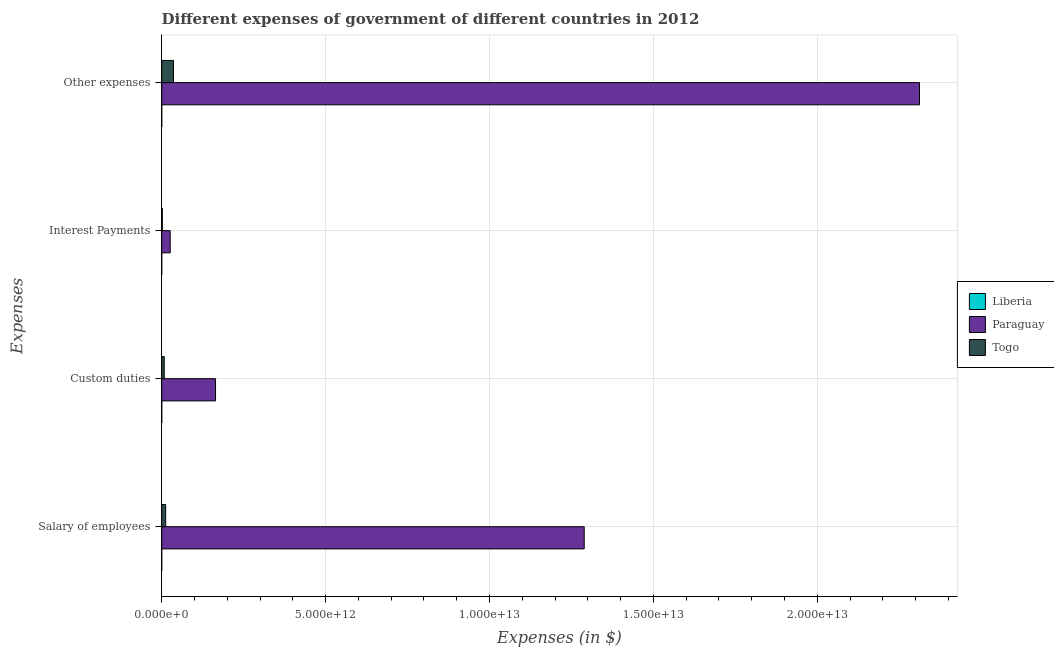Are the number of bars on each tick of the Y-axis equal?
Your answer should be very brief. Yes. How many bars are there on the 2nd tick from the top?
Provide a short and direct response. 3. What is the label of the 4th group of bars from the top?
Ensure brevity in your answer.  Salary of employees. What is the amount spent on salary of employees in Liberia?
Make the answer very short. 2.47e+06. Across all countries, what is the maximum amount spent on salary of employees?
Your answer should be very brief. 1.29e+13. Across all countries, what is the minimum amount spent on custom duties?
Provide a succinct answer. 1.73e+06. In which country was the amount spent on custom duties maximum?
Offer a terse response. Paraguay. In which country was the amount spent on custom duties minimum?
Your response must be concise. Liberia. What is the total amount spent on custom duties in the graph?
Your answer should be compact. 1.72e+12. What is the difference between the amount spent on custom duties in Togo and that in Liberia?
Ensure brevity in your answer.  7.70e+1. What is the difference between the amount spent on interest payments in Paraguay and the amount spent on salary of employees in Togo?
Offer a very short reply. 1.39e+11. What is the average amount spent on salary of employees per country?
Keep it short and to the point. 4.34e+12. What is the difference between the amount spent on salary of employees and amount spent on custom duties in Togo?
Provide a succinct answer. 4.34e+1. What is the ratio of the amount spent on interest payments in Liberia to that in Togo?
Provide a succinct answer. 2.492294683419937e-6. Is the amount spent on other expenses in Togo less than that in Liberia?
Give a very brief answer. No. Is the difference between the amount spent on salary of employees in Togo and Liberia greater than the difference between the amount spent on custom duties in Togo and Liberia?
Provide a short and direct response. Yes. What is the difference between the highest and the second highest amount spent on interest payments?
Give a very brief answer. 2.41e+11. What is the difference between the highest and the lowest amount spent on interest payments?
Offer a terse response. 2.59e+11. Is the sum of the amount spent on interest payments in Togo and Liberia greater than the maximum amount spent on custom duties across all countries?
Keep it short and to the point. No. What does the 3rd bar from the top in Salary of employees represents?
Offer a terse response. Liberia. What does the 1st bar from the bottom in Custom duties represents?
Make the answer very short. Liberia. Is it the case that in every country, the sum of the amount spent on salary of employees and amount spent on custom duties is greater than the amount spent on interest payments?
Offer a very short reply. Yes. What is the difference between two consecutive major ticks on the X-axis?
Ensure brevity in your answer.  5.00e+12. Are the values on the major ticks of X-axis written in scientific E-notation?
Your answer should be compact. Yes. What is the title of the graph?
Your answer should be compact. Different expenses of government of different countries in 2012. What is the label or title of the X-axis?
Your response must be concise. Expenses (in $). What is the label or title of the Y-axis?
Make the answer very short. Expenses. What is the Expenses (in $) of Liberia in Salary of employees?
Offer a very short reply. 2.47e+06. What is the Expenses (in $) of Paraguay in Salary of employees?
Offer a terse response. 1.29e+13. What is the Expenses (in $) in Togo in Salary of employees?
Ensure brevity in your answer.  1.20e+11. What is the Expenses (in $) of Liberia in Custom duties?
Ensure brevity in your answer.  1.73e+06. What is the Expenses (in $) of Paraguay in Custom duties?
Ensure brevity in your answer.  1.64e+12. What is the Expenses (in $) in Togo in Custom duties?
Ensure brevity in your answer.  7.70e+1. What is the Expenses (in $) in Liberia in Interest Payments?
Give a very brief answer. 4.63e+04. What is the Expenses (in $) of Paraguay in Interest Payments?
Your answer should be very brief. 2.59e+11. What is the Expenses (in $) in Togo in Interest Payments?
Provide a short and direct response. 1.86e+1. What is the Expenses (in $) in Liberia in Other expenses?
Provide a succinct answer. 5.86e+06. What is the Expenses (in $) in Paraguay in Other expenses?
Offer a terse response. 2.31e+13. What is the Expenses (in $) in Togo in Other expenses?
Ensure brevity in your answer.  3.60e+11. Across all Expenses, what is the maximum Expenses (in $) of Liberia?
Ensure brevity in your answer.  5.86e+06. Across all Expenses, what is the maximum Expenses (in $) of Paraguay?
Ensure brevity in your answer.  2.31e+13. Across all Expenses, what is the maximum Expenses (in $) in Togo?
Your answer should be very brief. 3.60e+11. Across all Expenses, what is the minimum Expenses (in $) of Liberia?
Provide a short and direct response. 4.63e+04. Across all Expenses, what is the minimum Expenses (in $) of Paraguay?
Your answer should be very brief. 2.59e+11. Across all Expenses, what is the minimum Expenses (in $) in Togo?
Provide a short and direct response. 1.86e+1. What is the total Expenses (in $) in Liberia in the graph?
Make the answer very short. 1.01e+07. What is the total Expenses (in $) of Paraguay in the graph?
Your answer should be compact. 3.79e+13. What is the total Expenses (in $) in Togo in the graph?
Offer a terse response. 5.76e+11. What is the difference between the Expenses (in $) in Liberia in Salary of employees and that in Custom duties?
Keep it short and to the point. 7.37e+05. What is the difference between the Expenses (in $) of Paraguay in Salary of employees and that in Custom duties?
Your answer should be very brief. 1.12e+13. What is the difference between the Expenses (in $) in Togo in Salary of employees and that in Custom duties?
Ensure brevity in your answer.  4.34e+1. What is the difference between the Expenses (in $) in Liberia in Salary of employees and that in Interest Payments?
Give a very brief answer. 2.42e+06. What is the difference between the Expenses (in $) in Paraguay in Salary of employees and that in Interest Payments?
Provide a succinct answer. 1.26e+13. What is the difference between the Expenses (in $) of Togo in Salary of employees and that in Interest Payments?
Keep it short and to the point. 1.02e+11. What is the difference between the Expenses (in $) of Liberia in Salary of employees and that in Other expenses?
Your answer should be very brief. -3.39e+06. What is the difference between the Expenses (in $) of Paraguay in Salary of employees and that in Other expenses?
Provide a short and direct response. -1.02e+13. What is the difference between the Expenses (in $) of Togo in Salary of employees and that in Other expenses?
Ensure brevity in your answer.  -2.39e+11. What is the difference between the Expenses (in $) of Liberia in Custom duties and that in Interest Payments?
Provide a succinct answer. 1.69e+06. What is the difference between the Expenses (in $) in Paraguay in Custom duties and that in Interest Payments?
Provide a succinct answer. 1.38e+12. What is the difference between the Expenses (in $) of Togo in Custom duties and that in Interest Payments?
Make the answer very short. 5.84e+1. What is the difference between the Expenses (in $) of Liberia in Custom duties and that in Other expenses?
Your response must be concise. -4.13e+06. What is the difference between the Expenses (in $) in Paraguay in Custom duties and that in Other expenses?
Keep it short and to the point. -2.15e+13. What is the difference between the Expenses (in $) of Togo in Custom duties and that in Other expenses?
Keep it short and to the point. -2.83e+11. What is the difference between the Expenses (in $) of Liberia in Interest Payments and that in Other expenses?
Keep it short and to the point. -5.81e+06. What is the difference between the Expenses (in $) in Paraguay in Interest Payments and that in Other expenses?
Provide a short and direct response. -2.29e+13. What is the difference between the Expenses (in $) in Togo in Interest Payments and that in Other expenses?
Offer a very short reply. -3.41e+11. What is the difference between the Expenses (in $) of Liberia in Salary of employees and the Expenses (in $) of Paraguay in Custom duties?
Ensure brevity in your answer.  -1.64e+12. What is the difference between the Expenses (in $) in Liberia in Salary of employees and the Expenses (in $) in Togo in Custom duties?
Provide a short and direct response. -7.70e+1. What is the difference between the Expenses (in $) of Paraguay in Salary of employees and the Expenses (in $) of Togo in Custom duties?
Provide a succinct answer. 1.28e+13. What is the difference between the Expenses (in $) of Liberia in Salary of employees and the Expenses (in $) of Paraguay in Interest Payments?
Provide a short and direct response. -2.59e+11. What is the difference between the Expenses (in $) in Liberia in Salary of employees and the Expenses (in $) in Togo in Interest Payments?
Give a very brief answer. -1.86e+1. What is the difference between the Expenses (in $) in Paraguay in Salary of employees and the Expenses (in $) in Togo in Interest Payments?
Give a very brief answer. 1.29e+13. What is the difference between the Expenses (in $) in Liberia in Salary of employees and the Expenses (in $) in Paraguay in Other expenses?
Keep it short and to the point. -2.31e+13. What is the difference between the Expenses (in $) in Liberia in Salary of employees and the Expenses (in $) in Togo in Other expenses?
Offer a very short reply. -3.60e+11. What is the difference between the Expenses (in $) in Paraguay in Salary of employees and the Expenses (in $) in Togo in Other expenses?
Provide a short and direct response. 1.25e+13. What is the difference between the Expenses (in $) of Liberia in Custom duties and the Expenses (in $) of Paraguay in Interest Payments?
Offer a very short reply. -2.59e+11. What is the difference between the Expenses (in $) in Liberia in Custom duties and the Expenses (in $) in Togo in Interest Payments?
Give a very brief answer. -1.86e+1. What is the difference between the Expenses (in $) of Paraguay in Custom duties and the Expenses (in $) of Togo in Interest Payments?
Keep it short and to the point. 1.62e+12. What is the difference between the Expenses (in $) of Liberia in Custom duties and the Expenses (in $) of Paraguay in Other expenses?
Offer a very short reply. -2.31e+13. What is the difference between the Expenses (in $) of Liberia in Custom duties and the Expenses (in $) of Togo in Other expenses?
Provide a succinct answer. -3.60e+11. What is the difference between the Expenses (in $) of Paraguay in Custom duties and the Expenses (in $) of Togo in Other expenses?
Provide a short and direct response. 1.28e+12. What is the difference between the Expenses (in $) of Liberia in Interest Payments and the Expenses (in $) of Paraguay in Other expenses?
Give a very brief answer. -2.31e+13. What is the difference between the Expenses (in $) in Liberia in Interest Payments and the Expenses (in $) in Togo in Other expenses?
Offer a very short reply. -3.60e+11. What is the difference between the Expenses (in $) of Paraguay in Interest Payments and the Expenses (in $) of Togo in Other expenses?
Keep it short and to the point. -1.00e+11. What is the average Expenses (in $) of Liberia per Expenses?
Offer a terse response. 2.53e+06. What is the average Expenses (in $) of Paraguay per Expenses?
Provide a short and direct response. 9.48e+12. What is the average Expenses (in $) of Togo per Expenses?
Ensure brevity in your answer.  1.44e+11. What is the difference between the Expenses (in $) of Liberia and Expenses (in $) of Paraguay in Salary of employees?
Keep it short and to the point. -1.29e+13. What is the difference between the Expenses (in $) in Liberia and Expenses (in $) in Togo in Salary of employees?
Provide a short and direct response. -1.20e+11. What is the difference between the Expenses (in $) of Paraguay and Expenses (in $) of Togo in Salary of employees?
Make the answer very short. 1.28e+13. What is the difference between the Expenses (in $) in Liberia and Expenses (in $) in Paraguay in Custom duties?
Your answer should be compact. -1.64e+12. What is the difference between the Expenses (in $) in Liberia and Expenses (in $) in Togo in Custom duties?
Provide a succinct answer. -7.70e+1. What is the difference between the Expenses (in $) of Paraguay and Expenses (in $) of Togo in Custom duties?
Ensure brevity in your answer.  1.57e+12. What is the difference between the Expenses (in $) of Liberia and Expenses (in $) of Paraguay in Interest Payments?
Give a very brief answer. -2.59e+11. What is the difference between the Expenses (in $) of Liberia and Expenses (in $) of Togo in Interest Payments?
Give a very brief answer. -1.86e+1. What is the difference between the Expenses (in $) in Paraguay and Expenses (in $) in Togo in Interest Payments?
Provide a succinct answer. 2.41e+11. What is the difference between the Expenses (in $) of Liberia and Expenses (in $) of Paraguay in Other expenses?
Keep it short and to the point. -2.31e+13. What is the difference between the Expenses (in $) of Liberia and Expenses (in $) of Togo in Other expenses?
Provide a succinct answer. -3.60e+11. What is the difference between the Expenses (in $) in Paraguay and Expenses (in $) in Togo in Other expenses?
Provide a short and direct response. 2.28e+13. What is the ratio of the Expenses (in $) of Liberia in Salary of employees to that in Custom duties?
Your answer should be compact. 1.43. What is the ratio of the Expenses (in $) in Paraguay in Salary of employees to that in Custom duties?
Provide a succinct answer. 7.85. What is the ratio of the Expenses (in $) in Togo in Salary of employees to that in Custom duties?
Your answer should be very brief. 1.56. What is the ratio of the Expenses (in $) of Liberia in Salary of employees to that in Interest Payments?
Give a very brief answer. 53.29. What is the ratio of the Expenses (in $) of Paraguay in Salary of employees to that in Interest Payments?
Ensure brevity in your answer.  49.71. What is the ratio of the Expenses (in $) of Togo in Salary of employees to that in Interest Payments?
Your response must be concise. 6.48. What is the ratio of the Expenses (in $) in Liberia in Salary of employees to that in Other expenses?
Provide a short and direct response. 0.42. What is the ratio of the Expenses (in $) of Paraguay in Salary of employees to that in Other expenses?
Offer a terse response. 0.56. What is the ratio of the Expenses (in $) in Togo in Salary of employees to that in Other expenses?
Keep it short and to the point. 0.33. What is the ratio of the Expenses (in $) of Liberia in Custom duties to that in Interest Payments?
Keep it short and to the point. 37.39. What is the ratio of the Expenses (in $) in Paraguay in Custom duties to that in Interest Payments?
Provide a short and direct response. 6.33. What is the ratio of the Expenses (in $) in Togo in Custom duties to that in Interest Payments?
Your response must be concise. 4.14. What is the ratio of the Expenses (in $) of Liberia in Custom duties to that in Other expenses?
Keep it short and to the point. 0.3. What is the ratio of the Expenses (in $) of Paraguay in Custom duties to that in Other expenses?
Give a very brief answer. 0.07. What is the ratio of the Expenses (in $) in Togo in Custom duties to that in Other expenses?
Your answer should be very brief. 0.21. What is the ratio of the Expenses (in $) in Liberia in Interest Payments to that in Other expenses?
Provide a short and direct response. 0.01. What is the ratio of the Expenses (in $) in Paraguay in Interest Payments to that in Other expenses?
Ensure brevity in your answer.  0.01. What is the ratio of the Expenses (in $) of Togo in Interest Payments to that in Other expenses?
Give a very brief answer. 0.05. What is the difference between the highest and the second highest Expenses (in $) of Liberia?
Provide a short and direct response. 3.39e+06. What is the difference between the highest and the second highest Expenses (in $) of Paraguay?
Make the answer very short. 1.02e+13. What is the difference between the highest and the second highest Expenses (in $) of Togo?
Your answer should be very brief. 2.39e+11. What is the difference between the highest and the lowest Expenses (in $) in Liberia?
Your response must be concise. 5.81e+06. What is the difference between the highest and the lowest Expenses (in $) in Paraguay?
Your response must be concise. 2.29e+13. What is the difference between the highest and the lowest Expenses (in $) in Togo?
Your answer should be compact. 3.41e+11. 